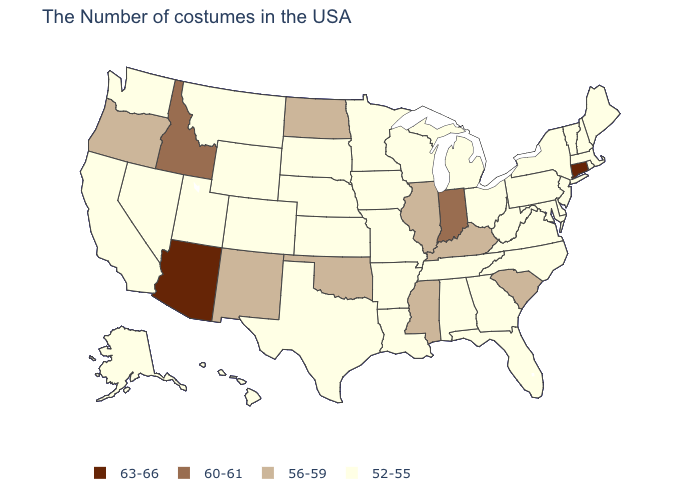Does Arizona have the highest value in the USA?
Concise answer only. Yes. What is the value of Illinois?
Write a very short answer. 56-59. Among the states that border New Mexico , which have the highest value?
Answer briefly. Arizona. Name the states that have a value in the range 52-55?
Concise answer only. Maine, Massachusetts, Rhode Island, New Hampshire, Vermont, New York, New Jersey, Delaware, Maryland, Pennsylvania, Virginia, North Carolina, West Virginia, Ohio, Florida, Georgia, Michigan, Alabama, Tennessee, Wisconsin, Louisiana, Missouri, Arkansas, Minnesota, Iowa, Kansas, Nebraska, Texas, South Dakota, Wyoming, Colorado, Utah, Montana, Nevada, California, Washington, Alaska, Hawaii. Does Utah have the highest value in the West?
Give a very brief answer. No. Name the states that have a value in the range 63-66?
Keep it brief. Connecticut, Arizona. Name the states that have a value in the range 60-61?
Quick response, please. Indiana, Idaho. What is the value of Wyoming?
Concise answer only. 52-55. Does Georgia have a higher value than Kentucky?
Quick response, please. No. Name the states that have a value in the range 60-61?
Concise answer only. Indiana, Idaho. Name the states that have a value in the range 56-59?
Answer briefly. South Carolina, Kentucky, Illinois, Mississippi, Oklahoma, North Dakota, New Mexico, Oregon. Among the states that border New Jersey , which have the highest value?
Concise answer only. New York, Delaware, Pennsylvania. Name the states that have a value in the range 63-66?
Answer briefly. Connecticut, Arizona. Which states have the lowest value in the USA?
Write a very short answer. Maine, Massachusetts, Rhode Island, New Hampshire, Vermont, New York, New Jersey, Delaware, Maryland, Pennsylvania, Virginia, North Carolina, West Virginia, Ohio, Florida, Georgia, Michigan, Alabama, Tennessee, Wisconsin, Louisiana, Missouri, Arkansas, Minnesota, Iowa, Kansas, Nebraska, Texas, South Dakota, Wyoming, Colorado, Utah, Montana, Nevada, California, Washington, Alaska, Hawaii. Which states hav the highest value in the South?
Short answer required. South Carolina, Kentucky, Mississippi, Oklahoma. 